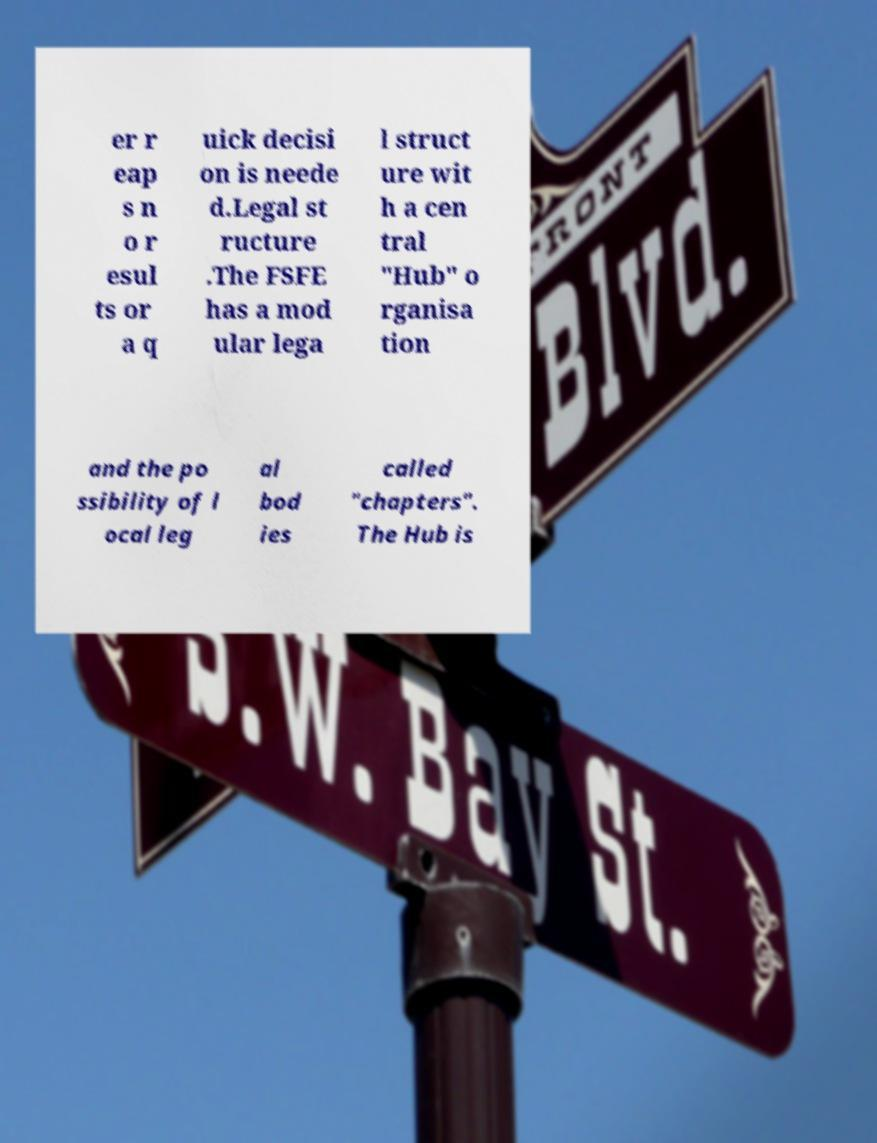Could you assist in decoding the text presented in this image and type it out clearly? er r eap s n o r esul ts or a q uick decisi on is neede d.Legal st ructure .The FSFE has a mod ular lega l struct ure wit h a cen tral "Hub" o rganisa tion and the po ssibility of l ocal leg al bod ies called "chapters". The Hub is 